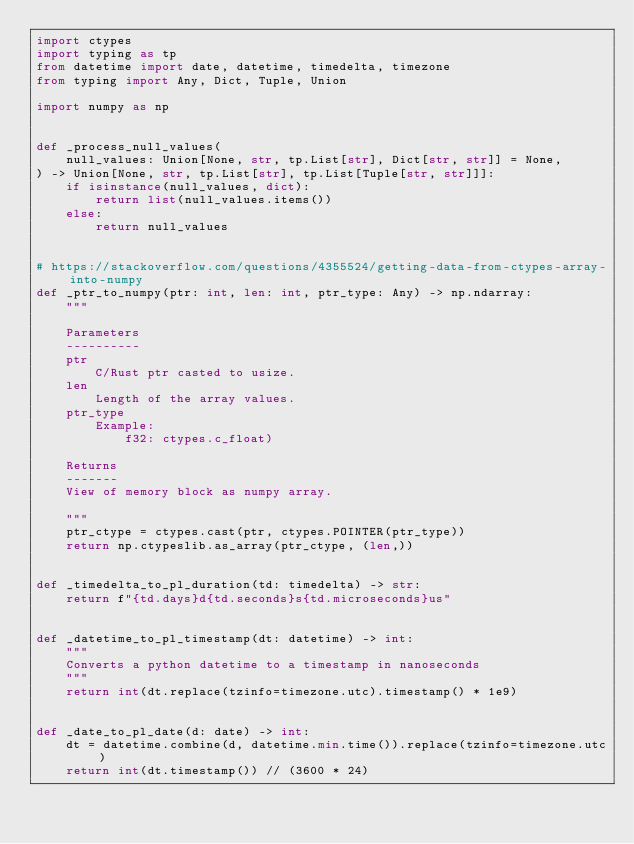<code> <loc_0><loc_0><loc_500><loc_500><_Python_>import ctypes
import typing as tp
from datetime import date, datetime, timedelta, timezone
from typing import Any, Dict, Tuple, Union

import numpy as np


def _process_null_values(
    null_values: Union[None, str, tp.List[str], Dict[str, str]] = None,
) -> Union[None, str, tp.List[str], tp.List[Tuple[str, str]]]:
    if isinstance(null_values, dict):
        return list(null_values.items())
    else:
        return null_values


# https://stackoverflow.com/questions/4355524/getting-data-from-ctypes-array-into-numpy
def _ptr_to_numpy(ptr: int, len: int, ptr_type: Any) -> np.ndarray:
    """

    Parameters
    ----------
    ptr
        C/Rust ptr casted to usize.
    len
        Length of the array values.
    ptr_type
        Example:
            f32: ctypes.c_float)

    Returns
    -------
    View of memory block as numpy array.

    """
    ptr_ctype = ctypes.cast(ptr, ctypes.POINTER(ptr_type))
    return np.ctypeslib.as_array(ptr_ctype, (len,))


def _timedelta_to_pl_duration(td: timedelta) -> str:
    return f"{td.days}d{td.seconds}s{td.microseconds}us"


def _datetime_to_pl_timestamp(dt: datetime) -> int:
    """
    Converts a python datetime to a timestamp in nanoseconds
    """
    return int(dt.replace(tzinfo=timezone.utc).timestamp() * 1e9)


def _date_to_pl_date(d: date) -> int:
    dt = datetime.combine(d, datetime.min.time()).replace(tzinfo=timezone.utc)
    return int(dt.timestamp()) // (3600 * 24)
</code> 